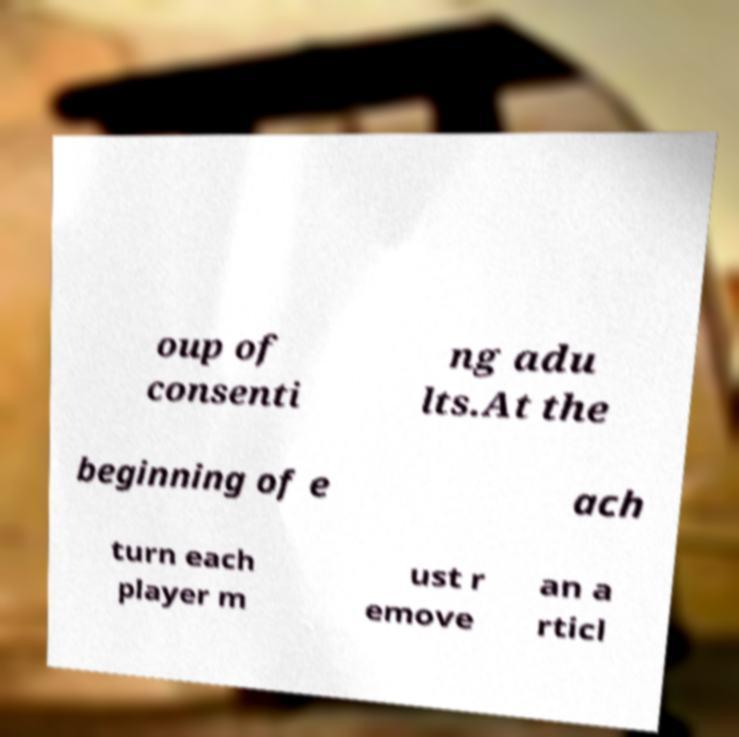Can you read and provide the text displayed in the image?This photo seems to have some interesting text. Can you extract and type it out for me? oup of consenti ng adu lts.At the beginning of e ach turn each player m ust r emove an a rticl 